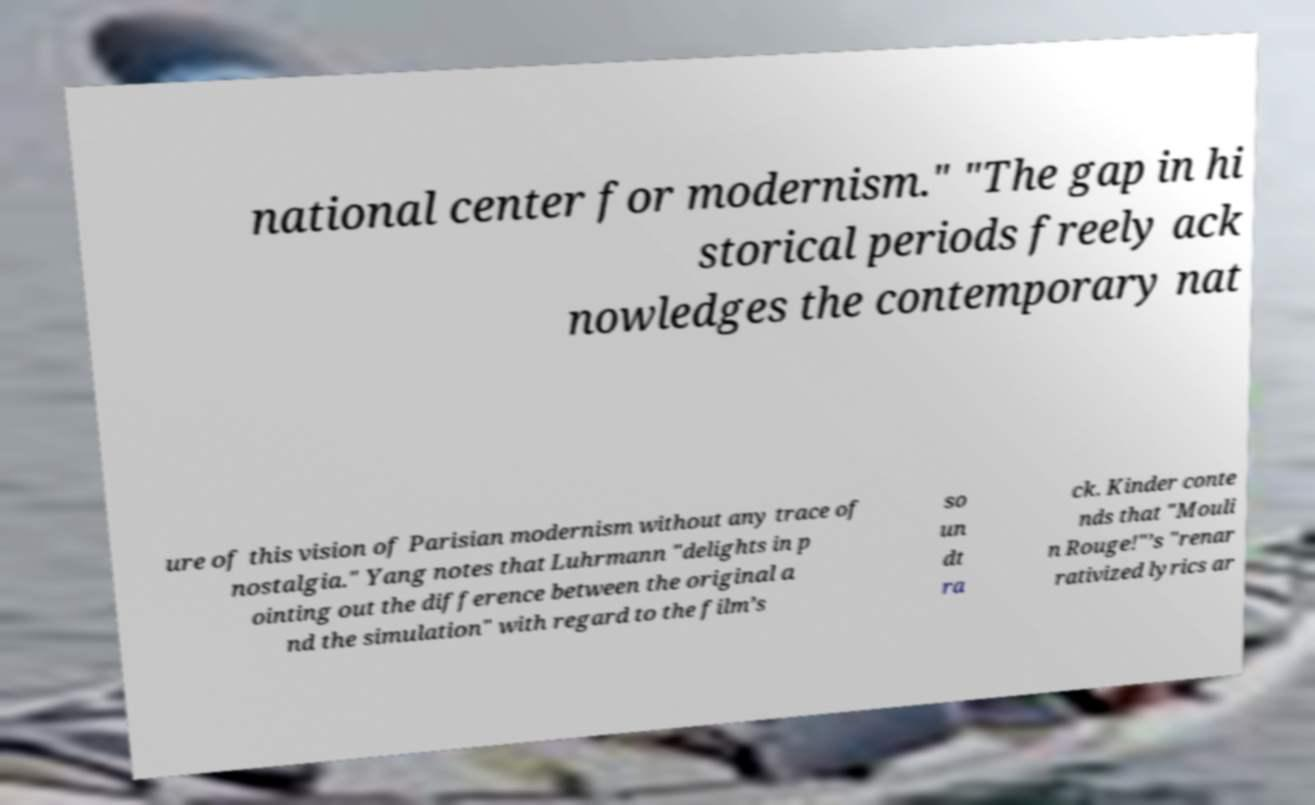Could you extract and type out the text from this image? national center for modernism." "The gap in hi storical periods freely ack nowledges the contemporary nat ure of this vision of Parisian modernism without any trace of nostalgia." Yang notes that Luhrmann "delights in p ointing out the difference between the original a nd the simulation" with regard to the film’s so un dt ra ck. Kinder conte nds that "Mouli n Rouge!"’s "renar rativized lyrics ar 